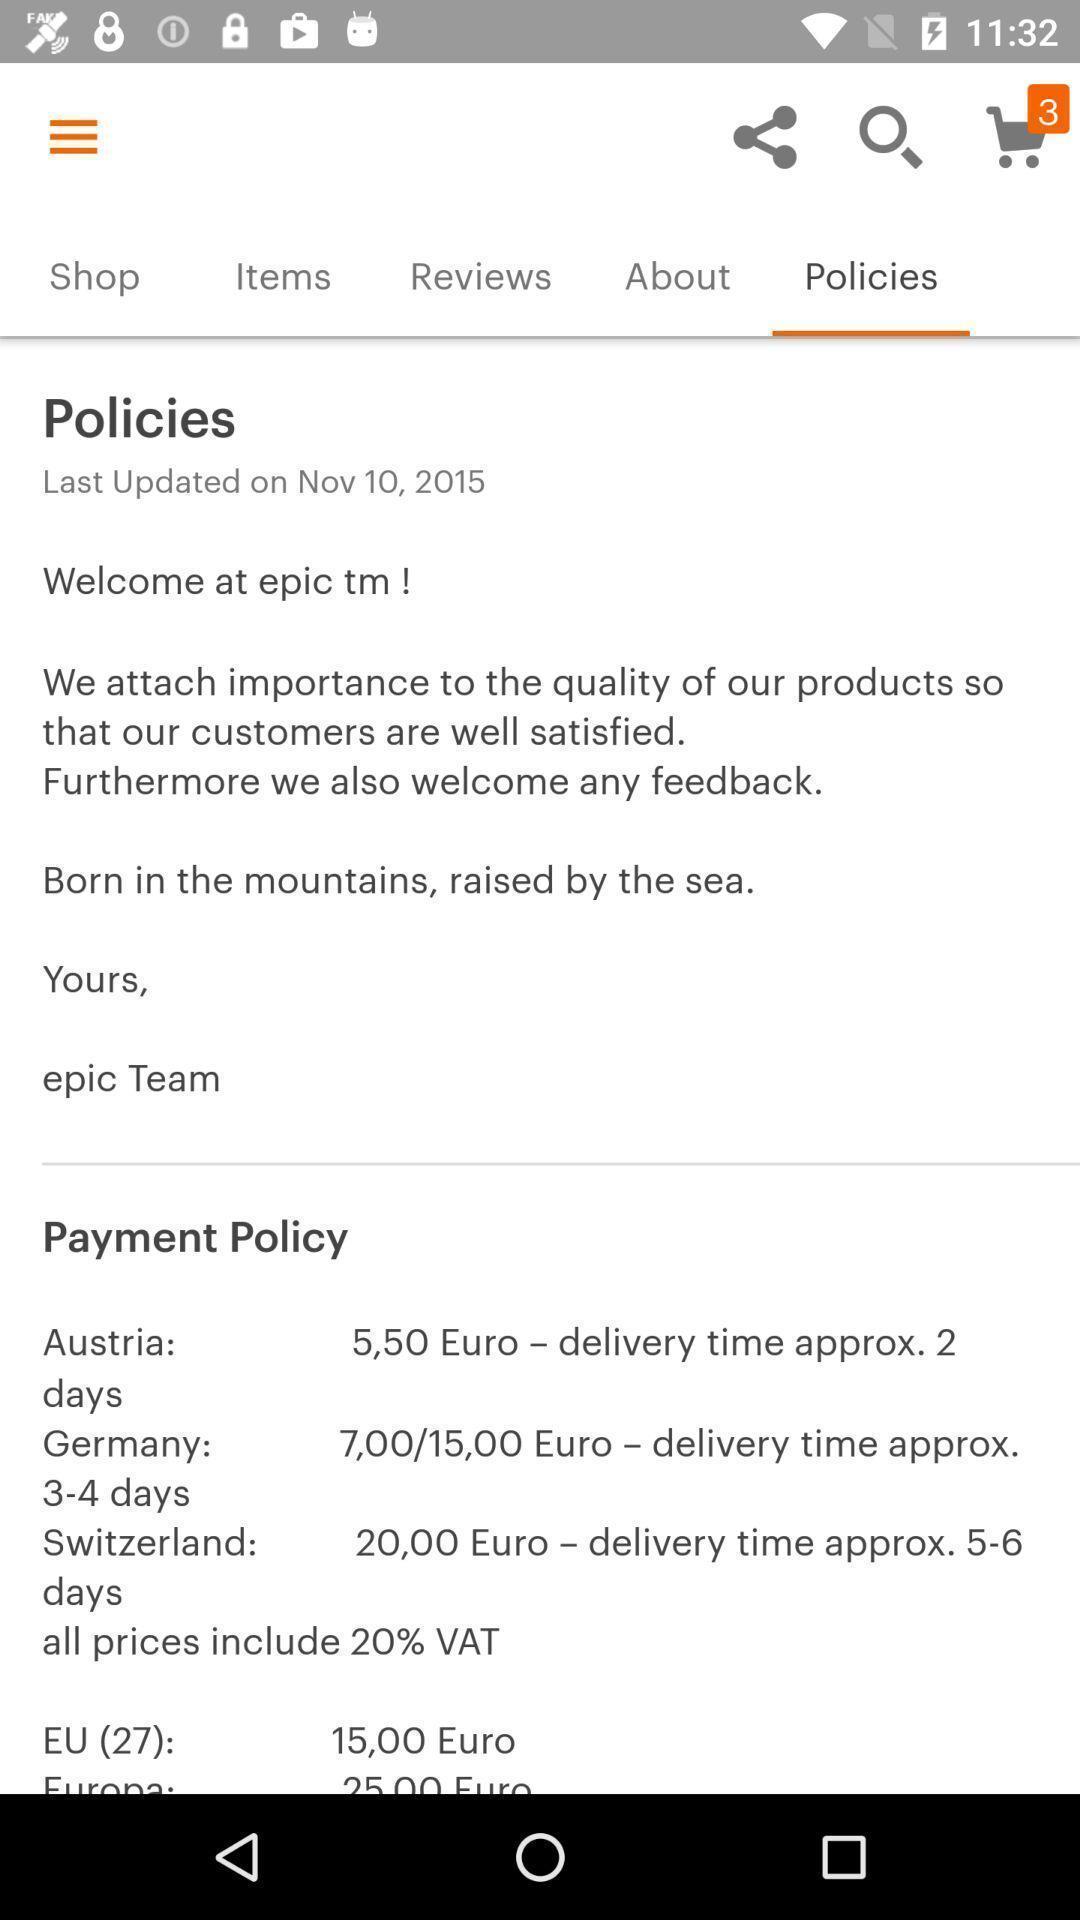Explain the elements present in this screenshot. Page with policies in a shopping app. 